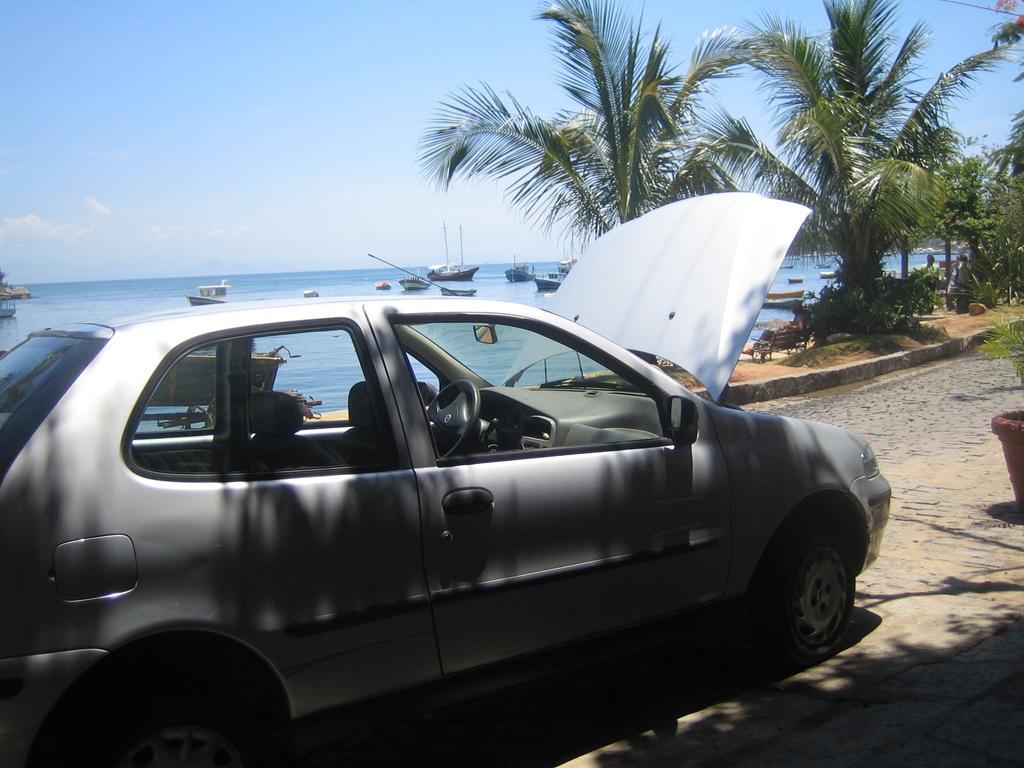Can you describe this image briefly? In this image I can see the vehicle. In the background I can see few trees in green color, few boats on the water and the sky is in blue and white color. 